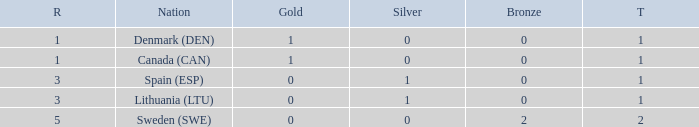What is the number of gold medals for Lithuania (ltu), when the total is more than 1? None. 